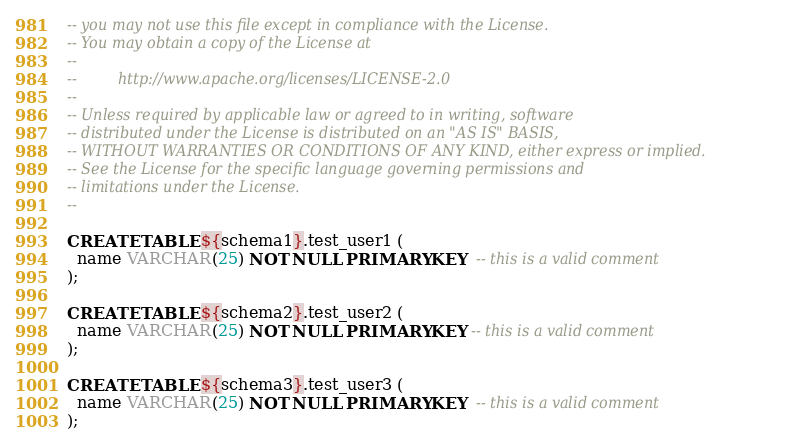Convert code to text. <code><loc_0><loc_0><loc_500><loc_500><_SQL_>-- you may not use this file except in compliance with the License.
-- You may obtain a copy of the License at
--
--         http://www.apache.org/licenses/LICENSE-2.0
--
-- Unless required by applicable law or agreed to in writing, software
-- distributed under the License is distributed on an "AS IS" BASIS,
-- WITHOUT WARRANTIES OR CONDITIONS OF ANY KIND, either express or implied.
-- See the License for the specific language governing permissions and
-- limitations under the License.
--

CREATE TABLE ${schema1}.test_user1 (
  name VARCHAR(25) NOT NULL PRIMARY KEY  -- this is a valid comment
);

CREATE TABLE ${schema2}.test_user2 (
  name VARCHAR(25) NOT NULL PRIMARY KEY -- this is a valid comment
);

CREATE TABLE ${schema3}.test_user3 (
  name VARCHAR(25) NOT NULL PRIMARY KEY  -- this is a valid comment
);
</code> 